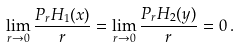Convert formula to latex. <formula><loc_0><loc_0><loc_500><loc_500>\lim _ { r \to 0 } \frac { P _ { r } H _ { 1 } ( x ) } { r } = \lim _ { r \to 0 } \frac { P _ { r } H _ { 2 } ( y ) } { r } = 0 \, .</formula> 